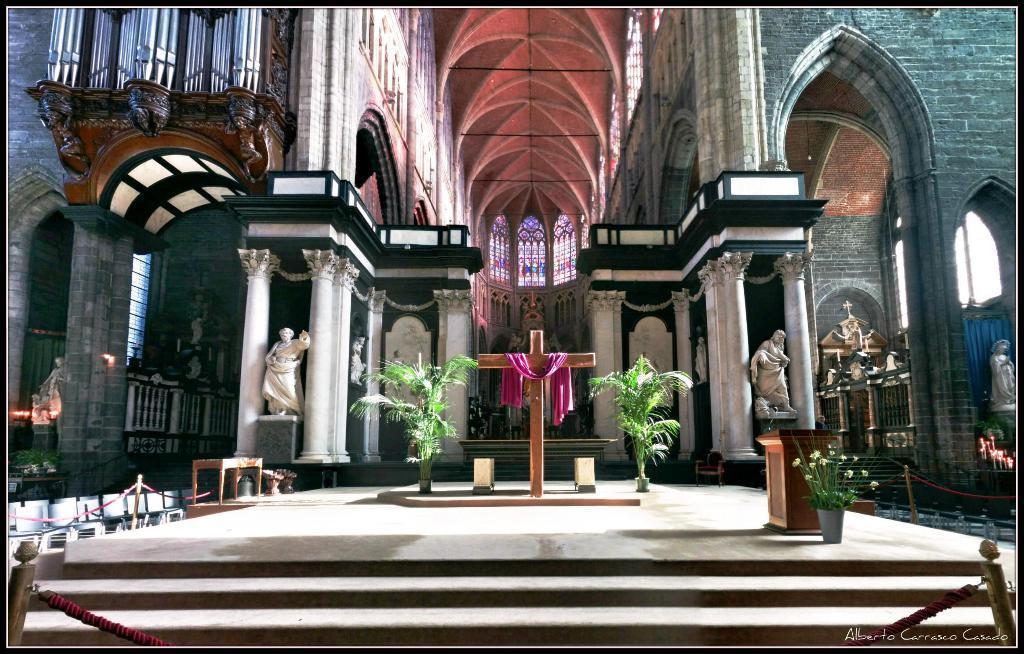In one or two sentences, can you explain what this image depicts? It is an inside view of the church. Here we can see few plants, holy cross, sculpture, pillars, walls, railings, chairs, ropes, poles and stairs. 